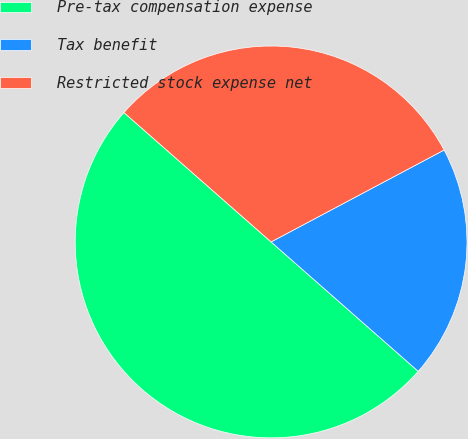Convert chart. <chart><loc_0><loc_0><loc_500><loc_500><pie_chart><fcel>Pre-tax compensation expense<fcel>Tax benefit<fcel>Restricted stock expense net<nl><fcel>50.0%<fcel>19.25%<fcel>30.75%<nl></chart> 